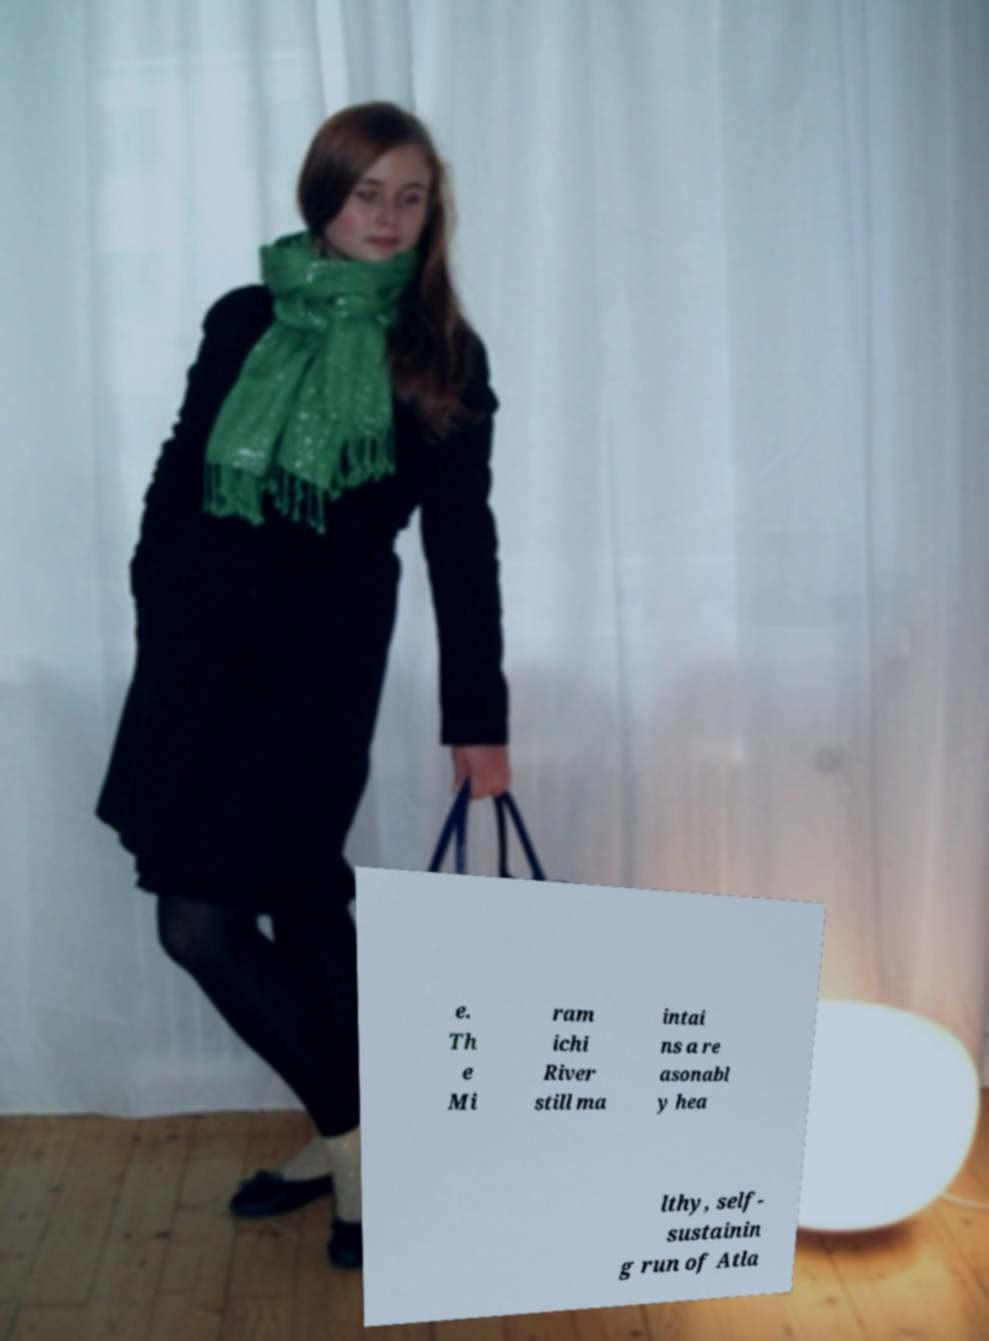Can you read and provide the text displayed in the image?This photo seems to have some interesting text. Can you extract and type it out for me? e. Th e Mi ram ichi River still ma intai ns a re asonabl y hea lthy, self- sustainin g run of Atla 